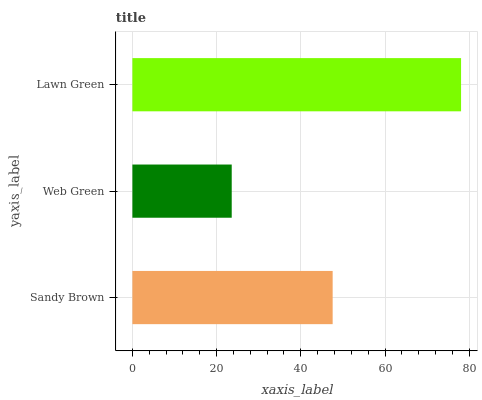Is Web Green the minimum?
Answer yes or no. Yes. Is Lawn Green the maximum?
Answer yes or no. Yes. Is Lawn Green the minimum?
Answer yes or no. No. Is Web Green the maximum?
Answer yes or no. No. Is Lawn Green greater than Web Green?
Answer yes or no. Yes. Is Web Green less than Lawn Green?
Answer yes or no. Yes. Is Web Green greater than Lawn Green?
Answer yes or no. No. Is Lawn Green less than Web Green?
Answer yes or no. No. Is Sandy Brown the high median?
Answer yes or no. Yes. Is Sandy Brown the low median?
Answer yes or no. Yes. Is Web Green the high median?
Answer yes or no. No. Is Web Green the low median?
Answer yes or no. No. 